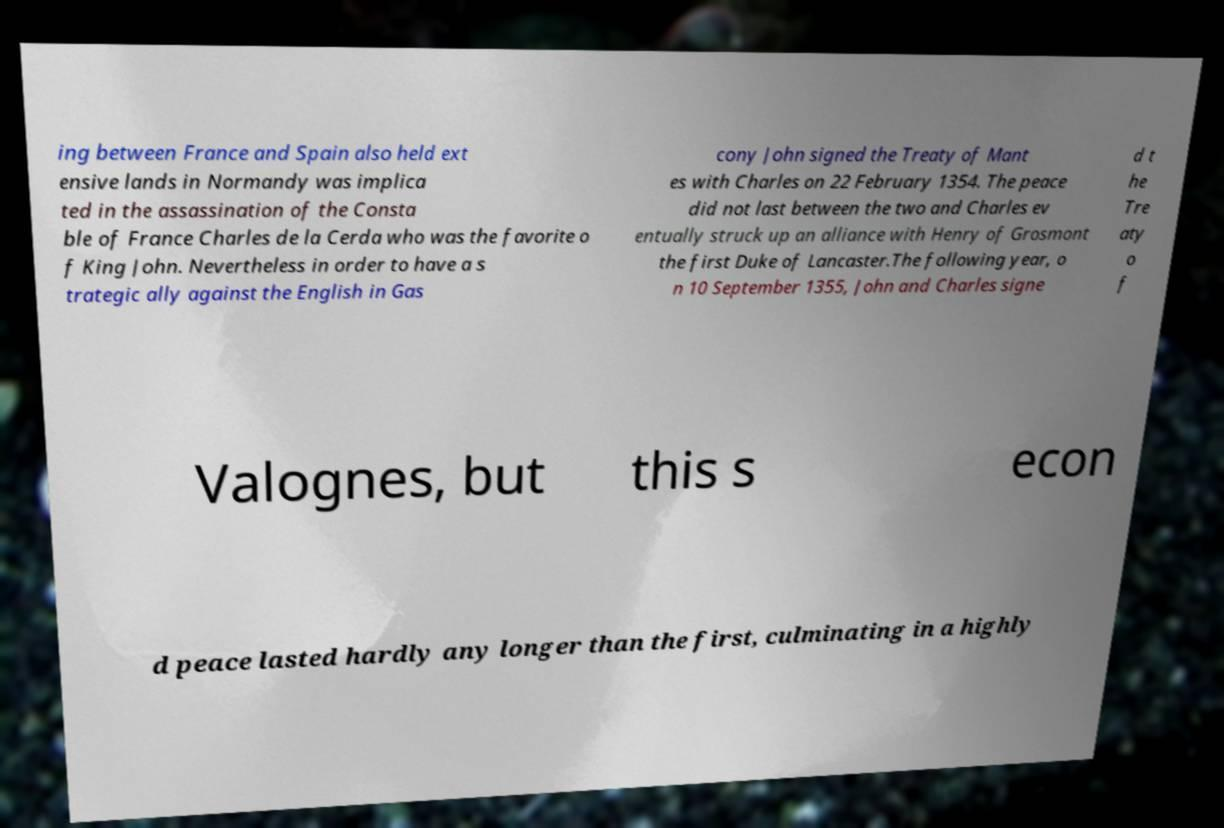What messages or text are displayed in this image? I need them in a readable, typed format. ing between France and Spain also held ext ensive lands in Normandy was implica ted in the assassination of the Consta ble of France Charles de la Cerda who was the favorite o f King John. Nevertheless in order to have a s trategic ally against the English in Gas cony John signed the Treaty of Mant es with Charles on 22 February 1354. The peace did not last between the two and Charles ev entually struck up an alliance with Henry of Grosmont the first Duke of Lancaster.The following year, o n 10 September 1355, John and Charles signe d t he Tre aty o f Valognes, but this s econ d peace lasted hardly any longer than the first, culminating in a highly 